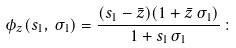<formula> <loc_0><loc_0><loc_500><loc_500>\phi _ { z } ( s _ { 1 } , \, \sigma _ { 1 } ) = \frac { ( s _ { 1 } - \bar { z } ) ( 1 + \bar { z } \, \sigma _ { 1 } ) } { 1 + s _ { 1 } \sigma _ { 1 } } \, \colon</formula> 